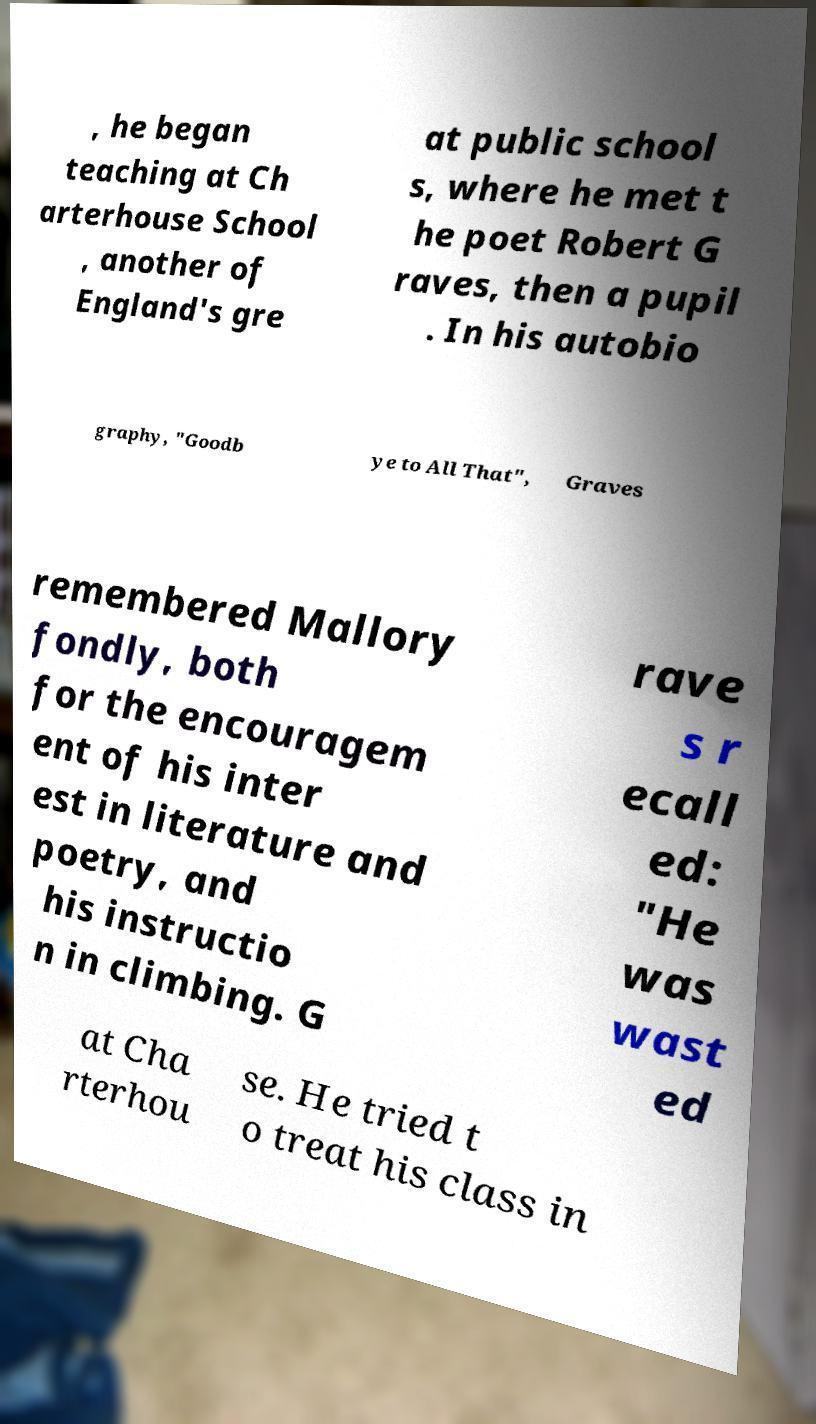Could you assist in decoding the text presented in this image and type it out clearly? , he began teaching at Ch arterhouse School , another of England's gre at public school s, where he met t he poet Robert G raves, then a pupil . In his autobio graphy, "Goodb ye to All That", Graves remembered Mallory fondly, both for the encouragem ent of his inter est in literature and poetry, and his instructio n in climbing. G rave s r ecall ed: "He was wast ed at Cha rterhou se. He tried t o treat his class in 